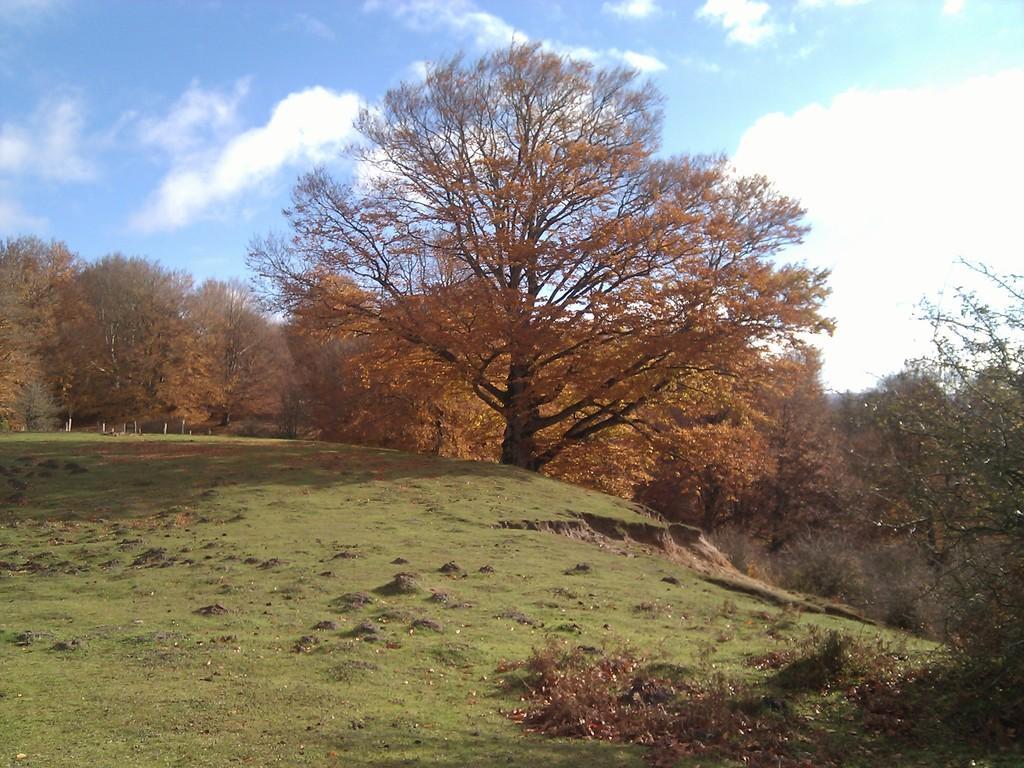Describe this image in one or two sentences. At the bottom of the image there is grass on the surface. In the background of the image there are trees and sky. 